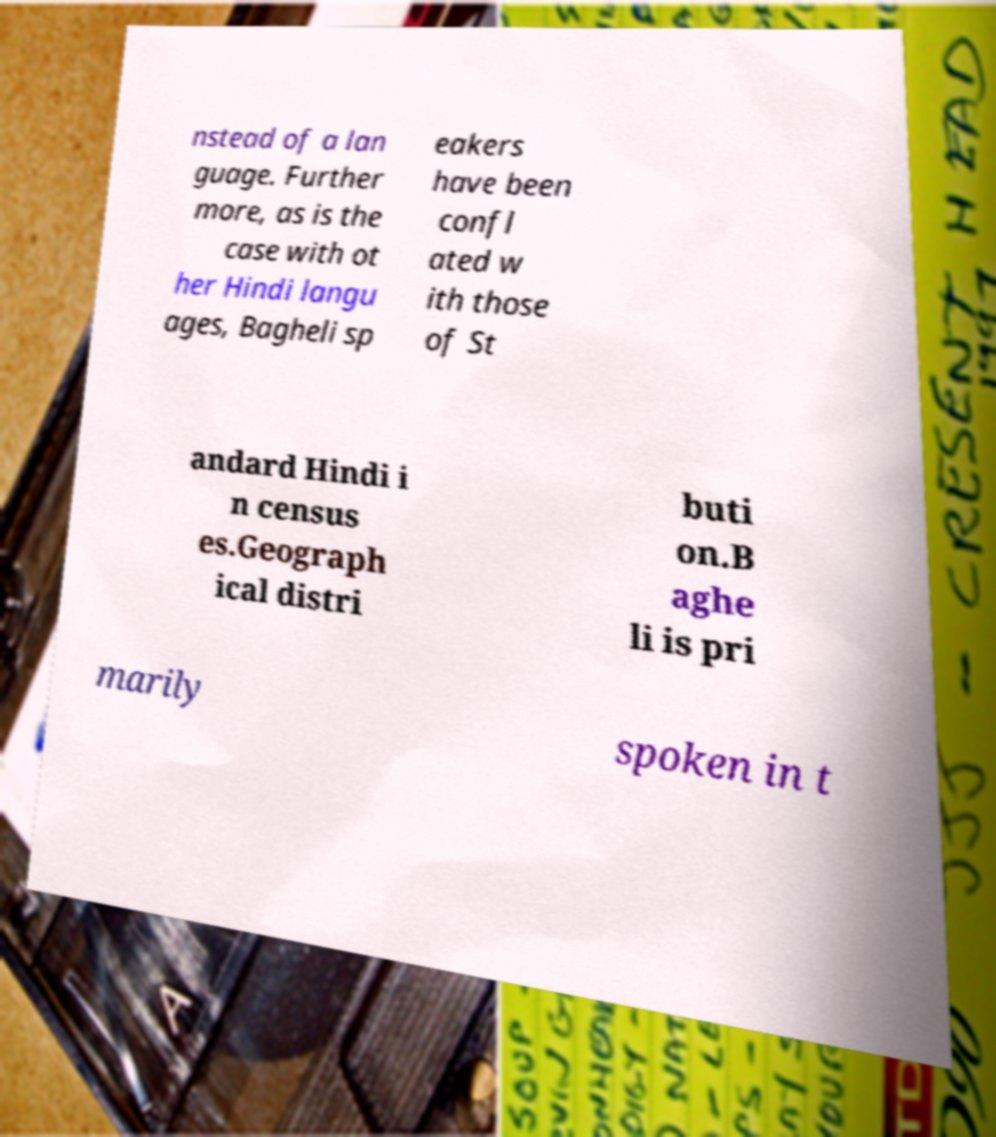Please identify and transcribe the text found in this image. nstead of a lan guage. Further more, as is the case with ot her Hindi langu ages, Bagheli sp eakers have been confl ated w ith those of St andard Hindi i n census es.Geograph ical distri buti on.B aghe li is pri marily spoken in t 